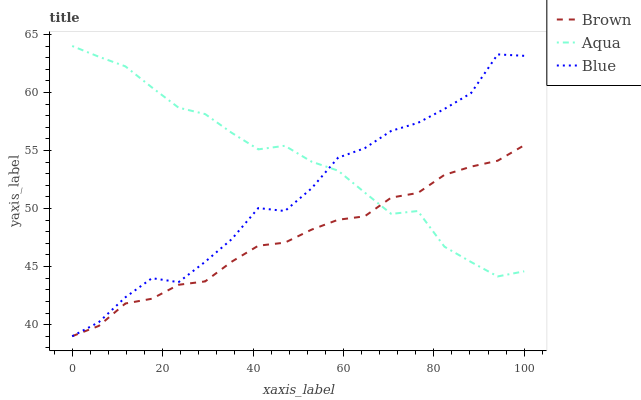Does Brown have the minimum area under the curve?
Answer yes or no. Yes. Does Aqua have the maximum area under the curve?
Answer yes or no. Yes. Does Aqua have the minimum area under the curve?
Answer yes or no. No. Does Brown have the maximum area under the curve?
Answer yes or no. No. Is Brown the smoothest?
Answer yes or no. Yes. Is Blue the roughest?
Answer yes or no. Yes. Is Aqua the smoothest?
Answer yes or no. No. Is Aqua the roughest?
Answer yes or no. No. Does Blue have the lowest value?
Answer yes or no. Yes. Does Brown have the lowest value?
Answer yes or no. No. Does Aqua have the highest value?
Answer yes or no. Yes. Does Brown have the highest value?
Answer yes or no. No. Does Aqua intersect Brown?
Answer yes or no. Yes. Is Aqua less than Brown?
Answer yes or no. No. Is Aqua greater than Brown?
Answer yes or no. No. 